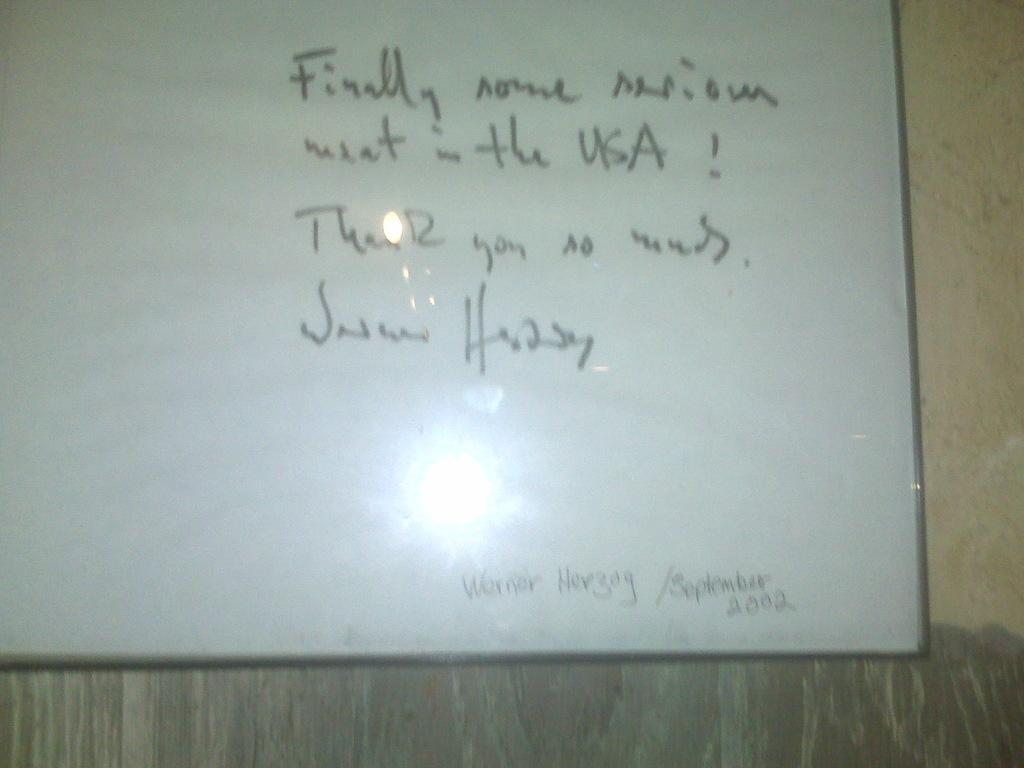<image>
Give a short and clear explanation of the subsequent image. A thank you message that is written on a board. 